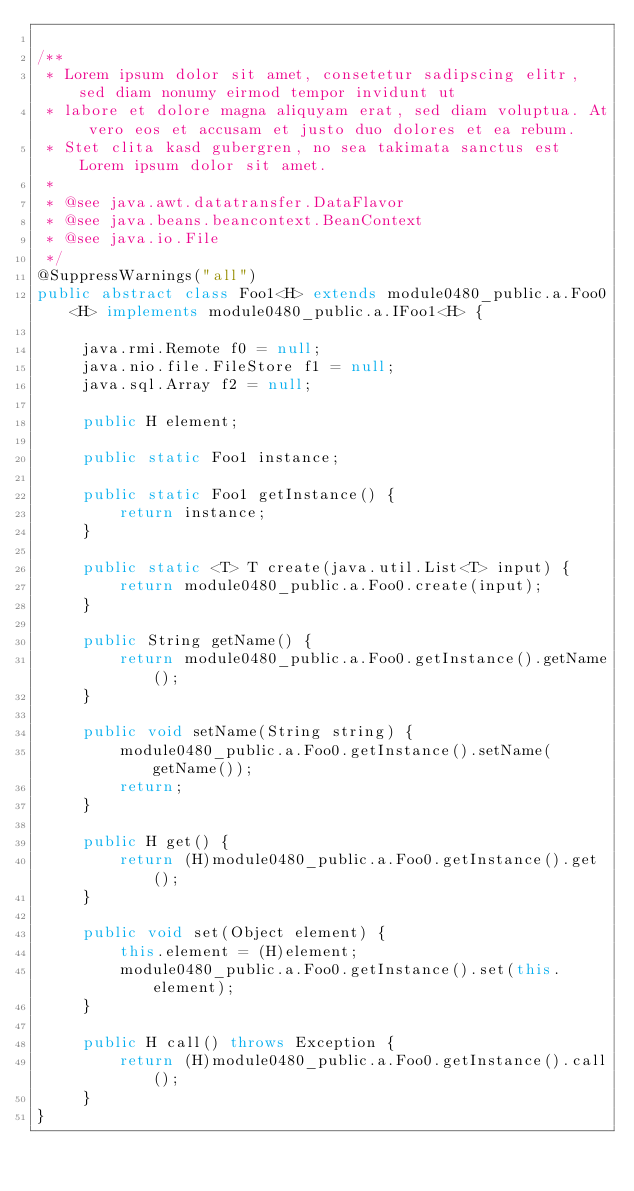<code> <loc_0><loc_0><loc_500><loc_500><_Java_>
/**
 * Lorem ipsum dolor sit amet, consetetur sadipscing elitr, sed diam nonumy eirmod tempor invidunt ut 
 * labore et dolore magna aliquyam erat, sed diam voluptua. At vero eos et accusam et justo duo dolores et ea rebum. 
 * Stet clita kasd gubergren, no sea takimata sanctus est Lorem ipsum dolor sit amet. 
 *
 * @see java.awt.datatransfer.DataFlavor
 * @see java.beans.beancontext.BeanContext
 * @see java.io.File
 */
@SuppressWarnings("all")
public abstract class Foo1<H> extends module0480_public.a.Foo0<H> implements module0480_public.a.IFoo1<H> {

	 java.rmi.Remote f0 = null;
	 java.nio.file.FileStore f1 = null;
	 java.sql.Array f2 = null;

	 public H element;

	 public static Foo1 instance;

	 public static Foo1 getInstance() {
	 	 return instance;
	 }

	 public static <T> T create(java.util.List<T> input) {
	 	 return module0480_public.a.Foo0.create(input);
	 }

	 public String getName() {
	 	 return module0480_public.a.Foo0.getInstance().getName();
	 }

	 public void setName(String string) {
	 	 module0480_public.a.Foo0.getInstance().setName(getName());
	 	 return;
	 }

	 public H get() {
	 	 return (H)module0480_public.a.Foo0.getInstance().get();
	 }

	 public void set(Object element) {
	 	 this.element = (H)element;
	 	 module0480_public.a.Foo0.getInstance().set(this.element);
	 }

	 public H call() throws Exception {
	 	 return (H)module0480_public.a.Foo0.getInstance().call();
	 }
}
</code> 